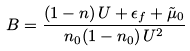<formula> <loc_0><loc_0><loc_500><loc_500>B = \frac { ( 1 - n ) \, U + \epsilon _ { f } + \tilde { \mu } _ { 0 } } { n _ { 0 } ( 1 - n _ { 0 } ) \, U ^ { 2 } }</formula> 